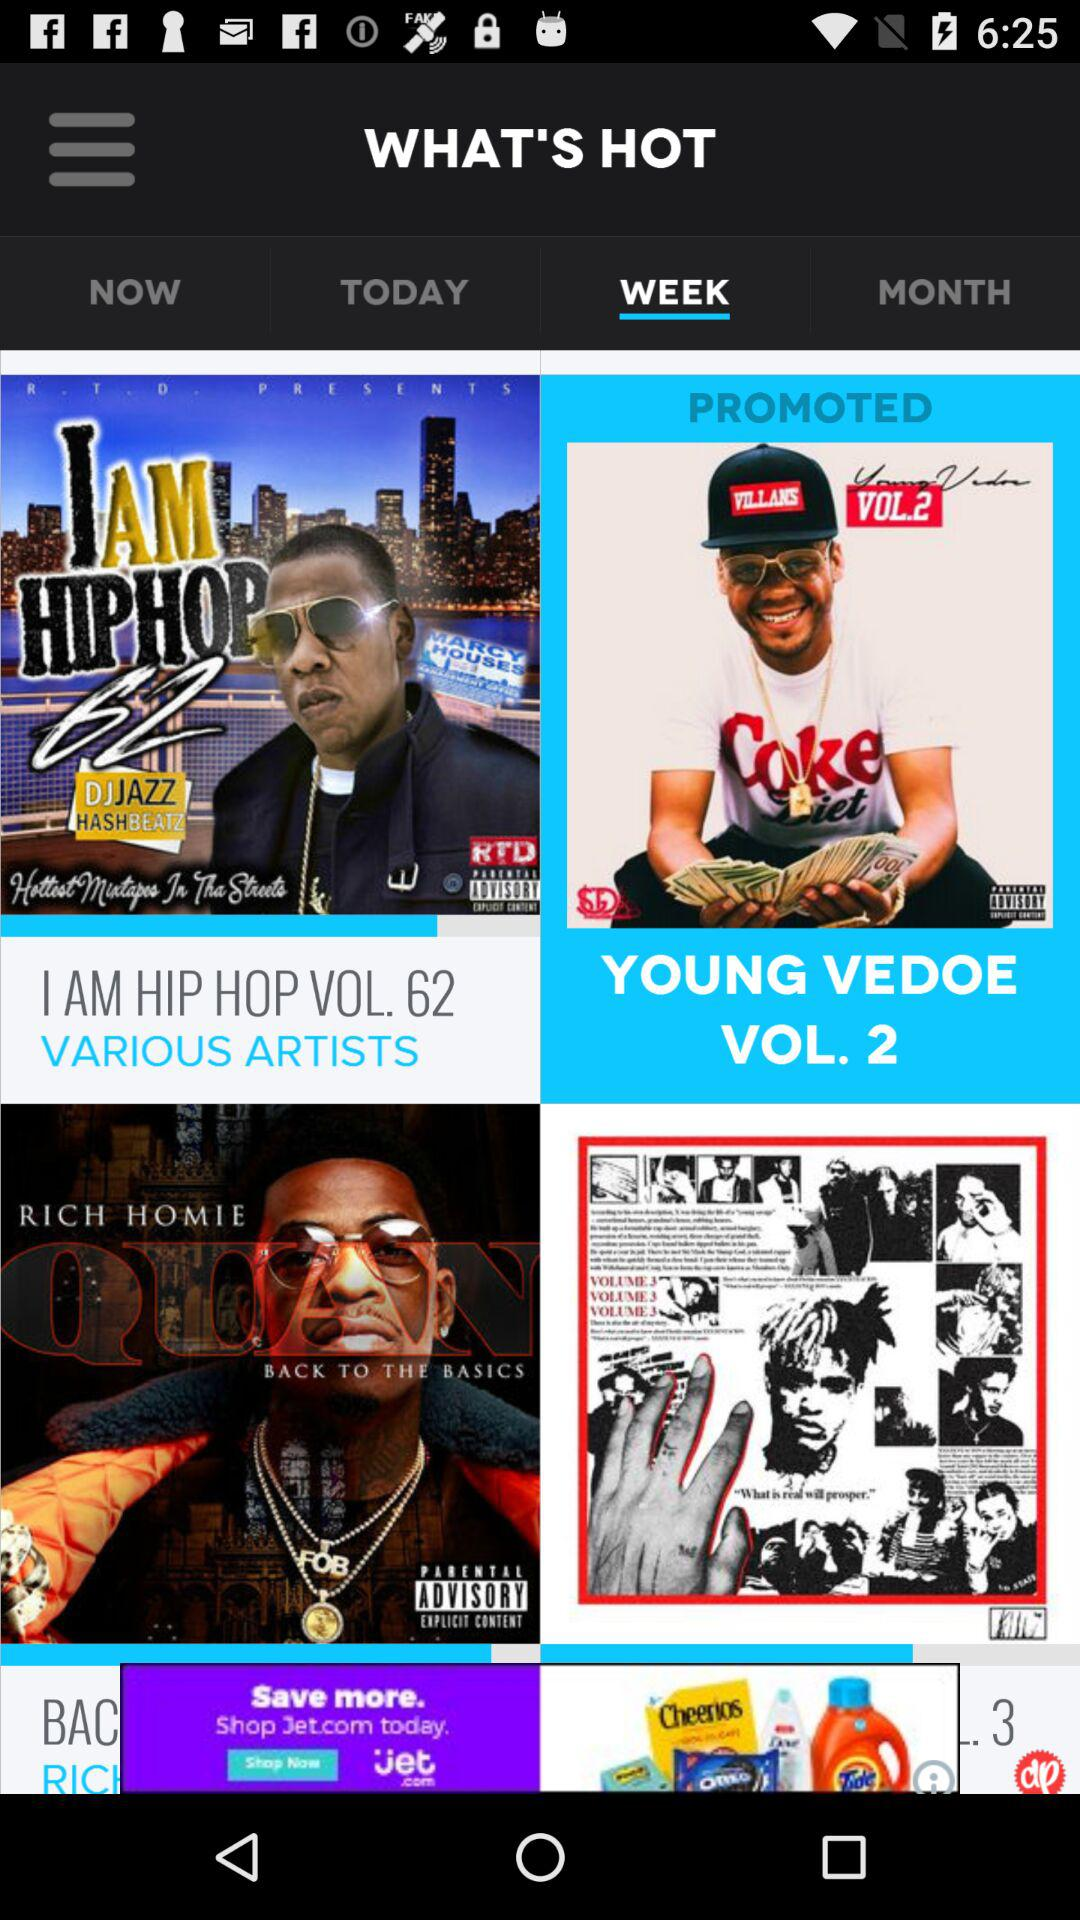Which tab is selected? The selected tab is a week. 